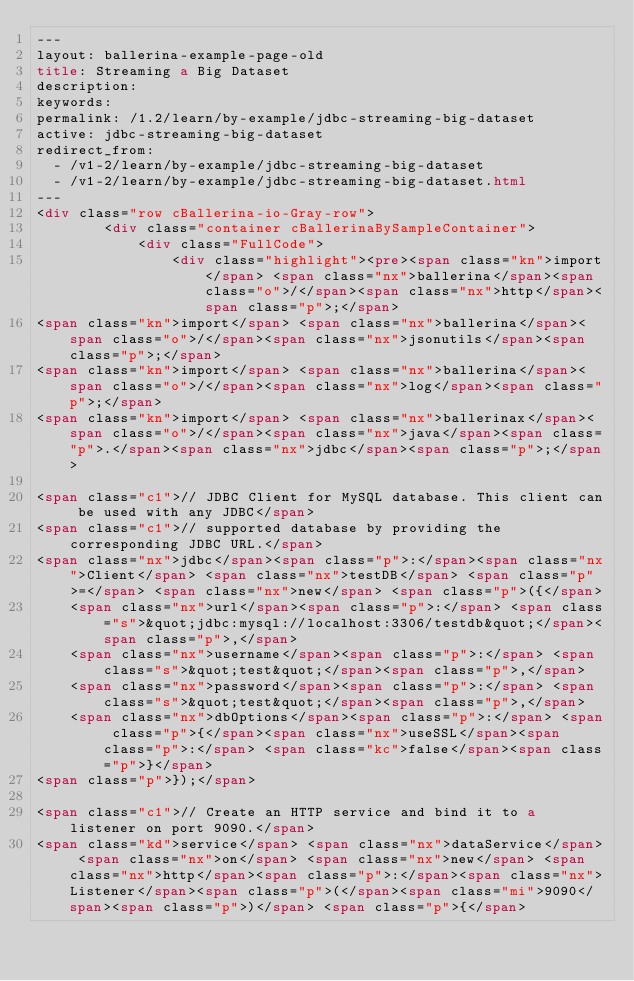Convert code to text. <code><loc_0><loc_0><loc_500><loc_500><_HTML_>---
layout: ballerina-example-page-old
title: Streaming a Big Dataset
description: 
keywords: 
permalink: /1.2/learn/by-example/jdbc-streaming-big-dataset
active: jdbc-streaming-big-dataset
redirect_from:
  - /v1-2/learn/by-example/jdbc-streaming-big-dataset
  - /v1-2/learn/by-example/jdbc-streaming-big-dataset.html
---
<div class="row cBallerina-io-Gray-row">
        <div class="container cBallerinaBySampleContainer">
            <div class="FullCode">
                <div class="highlight"><pre><span class="kn">import</span> <span class="nx">ballerina</span><span class="o">/</span><span class="nx">http</span><span class="p">;</span>
<span class="kn">import</span> <span class="nx">ballerina</span><span class="o">/</span><span class="nx">jsonutils</span><span class="p">;</span>
<span class="kn">import</span> <span class="nx">ballerina</span><span class="o">/</span><span class="nx">log</span><span class="p">;</span>
<span class="kn">import</span> <span class="nx">ballerinax</span><span class="o">/</span><span class="nx">java</span><span class="p">.</span><span class="nx">jdbc</span><span class="p">;</span>

<span class="c1">// JDBC Client for MySQL database. This client can be used with any JDBC</span>
<span class="c1">// supported database by providing the corresponding JDBC URL.</span>
<span class="nx">jdbc</span><span class="p">:</span><span class="nx">Client</span> <span class="nx">testDB</span> <span class="p">=</span> <span class="nx">new</span> <span class="p">({</span>
    <span class="nx">url</span><span class="p">:</span> <span class="s">&quot;jdbc:mysql://localhost:3306/testdb&quot;</span><span class="p">,</span>
    <span class="nx">username</span><span class="p">:</span> <span class="s">&quot;test&quot;</span><span class="p">,</span>
    <span class="nx">password</span><span class="p">:</span> <span class="s">&quot;test&quot;</span><span class="p">,</span>
    <span class="nx">dbOptions</span><span class="p">:</span> <span class="p">{</span><span class="nx">useSSL</span><span class="p">:</span> <span class="kc">false</span><span class="p">}</span>
<span class="p">});</span>

<span class="c1">// Create an HTTP service and bind it to a listener on port 9090.</span>
<span class="kd">service</span> <span class="nx">dataService</span> <span class="nx">on</span> <span class="nx">new</span> <span class="nx">http</span><span class="p">:</span><span class="nx">Listener</span><span class="p">(</span><span class="mi">9090</span><span class="p">)</span> <span class="p">{</span>
</code> 